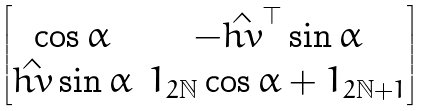<formula> <loc_0><loc_0><loc_500><loc_500>\begin{bmatrix} \cos \alpha & - \hat { h v } ^ { \top } \sin \alpha \\ \hat { h v } \sin \alpha & 1 _ { 2 \mathbb { N } } \cos \alpha + 1 _ { 2 \mathbb { N } + 1 } \end{bmatrix}</formula> 